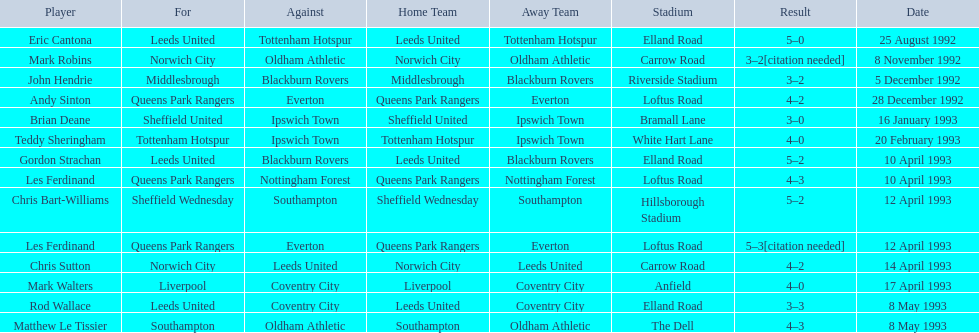Who are all the players? Eric Cantona, Mark Robins, John Hendrie, Andy Sinton, Brian Deane, Teddy Sheringham, Gordon Strachan, Les Ferdinand, Chris Bart-Williams, Les Ferdinand, Chris Sutton, Mark Walters, Rod Wallace, Matthew Le Tissier. What were their results? 5–0, 3–2[citation needed], 3–2, 4–2, 3–0, 4–0, 5–2, 4–3, 5–2, 5–3[citation needed], 4–2, 4–0, 3–3, 4–3. Which player tied with mark robins? John Hendrie. 